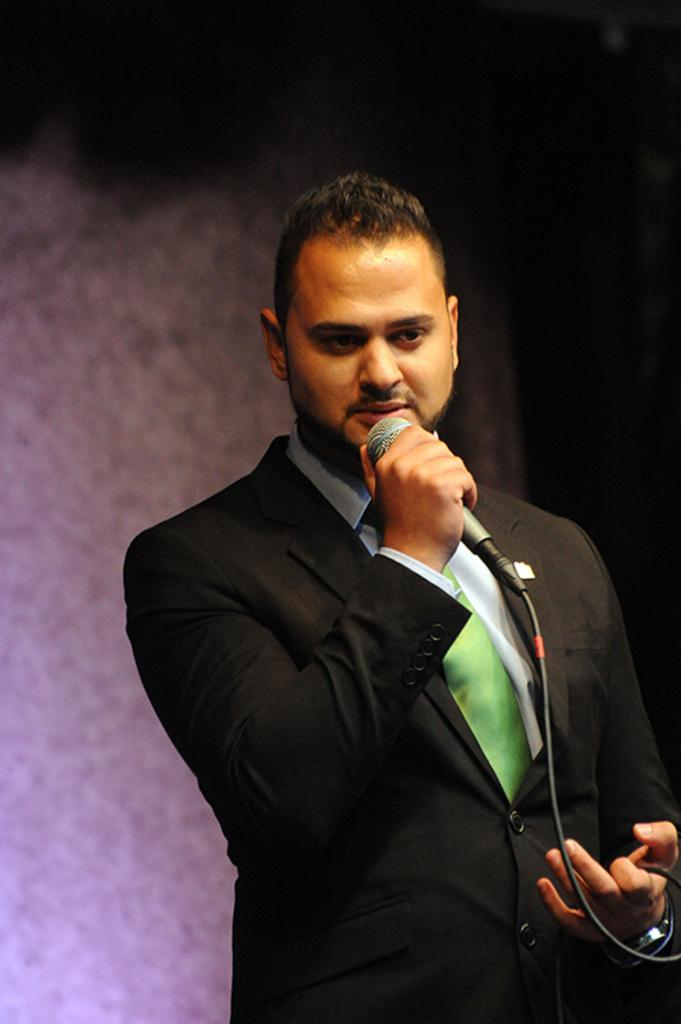Who is present in the image? There is a man in the image. What is the man doing in the image? The man is standing in the image. What object is the man holding in the image? The man is holding a microphone in the image. What can be seen in the background of the image? There is a wall in the background of the image. What type of rose can be seen on the man's shirt in the image? There is no rose visible on the man's shirt in the image. What type of food is the man eating in the image? The man is not eating any food in the image; he is holding a microphone. 